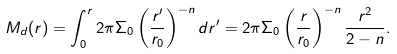<formula> <loc_0><loc_0><loc_500><loc_500>M _ { d } ( r ) = \int _ { 0 } ^ { r } 2 \pi \Sigma _ { 0 } \left ( \frac { r ^ { \prime } } { r _ { 0 } } \right ) ^ { - n } d r ^ { \prime } = 2 \pi \Sigma _ { 0 } \left ( \frac { r } { r _ { 0 } } \right ) ^ { - n } \frac { r ^ { 2 } } { 2 - n } .</formula> 